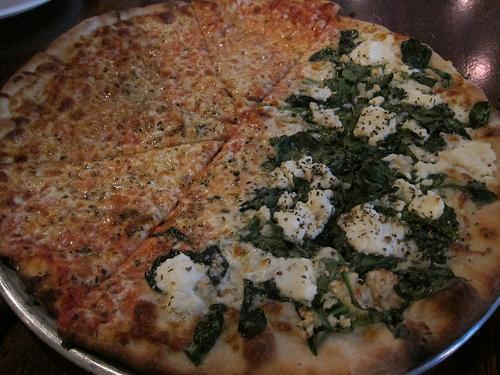How many flavors of pizza?
Give a very brief answer. 2. 